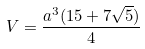<formula> <loc_0><loc_0><loc_500><loc_500>V = \frac { a ^ { 3 } ( 1 5 + 7 \sqrt { 5 } ) } { 4 }</formula> 